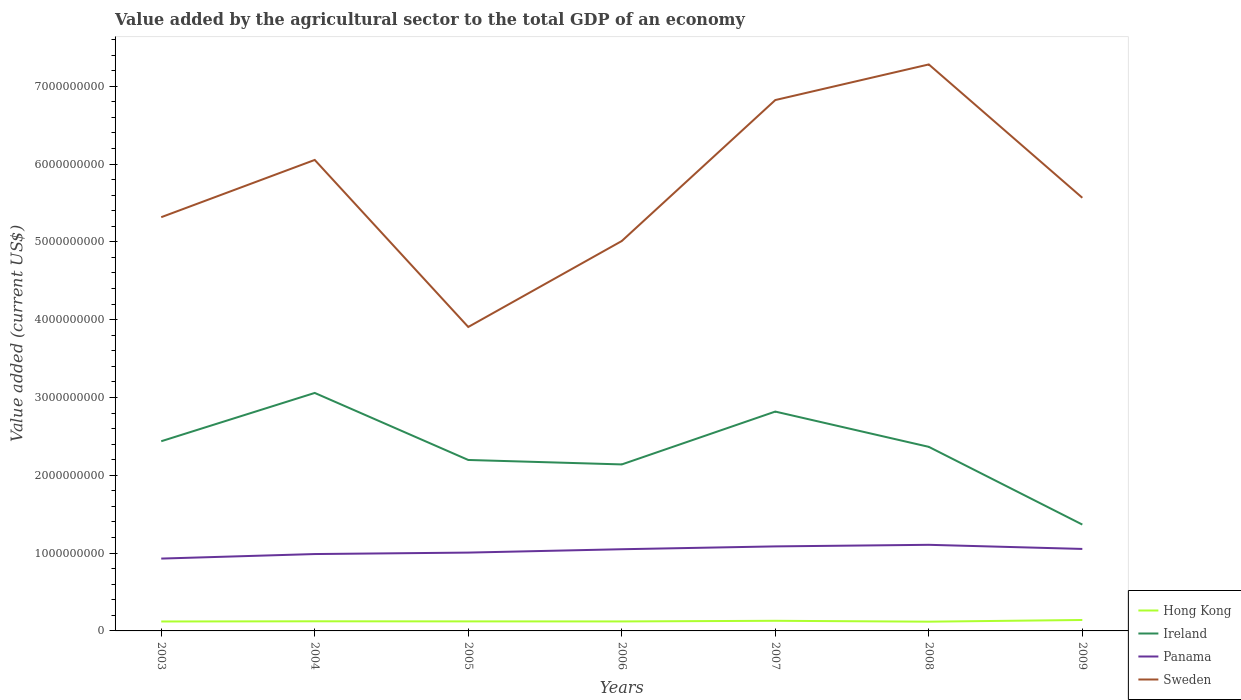How many different coloured lines are there?
Ensure brevity in your answer.  4. Is the number of lines equal to the number of legend labels?
Provide a succinct answer. Yes. Across all years, what is the maximum value added by the agricultural sector to the total GDP in Hong Kong?
Provide a short and direct response. 1.19e+08. In which year was the value added by the agricultural sector to the total GDP in Panama maximum?
Your response must be concise. 2003. What is the total value added by the agricultural sector to the total GDP in Ireland in the graph?
Offer a very short reply. 7.73e+08. What is the difference between the highest and the second highest value added by the agricultural sector to the total GDP in Panama?
Make the answer very short. 1.77e+08. What is the difference between the highest and the lowest value added by the agricultural sector to the total GDP in Sweden?
Offer a terse response. 3. How many lines are there?
Your answer should be compact. 4. Are the values on the major ticks of Y-axis written in scientific E-notation?
Your answer should be compact. No. Where does the legend appear in the graph?
Your answer should be very brief. Bottom right. How many legend labels are there?
Provide a succinct answer. 4. What is the title of the graph?
Your answer should be compact. Value added by the agricultural sector to the total GDP of an economy. Does "Montenegro" appear as one of the legend labels in the graph?
Give a very brief answer. No. What is the label or title of the Y-axis?
Give a very brief answer. Value added (current US$). What is the Value added (current US$) of Hong Kong in 2003?
Give a very brief answer. 1.21e+08. What is the Value added (current US$) of Ireland in 2003?
Provide a short and direct response. 2.44e+09. What is the Value added (current US$) of Panama in 2003?
Ensure brevity in your answer.  9.30e+08. What is the Value added (current US$) of Sweden in 2003?
Your answer should be very brief. 5.32e+09. What is the Value added (current US$) of Hong Kong in 2004?
Your answer should be compact. 1.24e+08. What is the Value added (current US$) in Ireland in 2004?
Keep it short and to the point. 3.06e+09. What is the Value added (current US$) of Panama in 2004?
Keep it short and to the point. 9.88e+08. What is the Value added (current US$) in Sweden in 2004?
Ensure brevity in your answer.  6.05e+09. What is the Value added (current US$) in Hong Kong in 2005?
Your answer should be very brief. 1.23e+08. What is the Value added (current US$) of Ireland in 2005?
Keep it short and to the point. 2.20e+09. What is the Value added (current US$) in Panama in 2005?
Keep it short and to the point. 1.01e+09. What is the Value added (current US$) of Sweden in 2005?
Offer a very short reply. 3.91e+09. What is the Value added (current US$) of Hong Kong in 2006?
Your answer should be very brief. 1.22e+08. What is the Value added (current US$) in Ireland in 2006?
Give a very brief answer. 2.14e+09. What is the Value added (current US$) of Panama in 2006?
Make the answer very short. 1.05e+09. What is the Value added (current US$) of Sweden in 2006?
Give a very brief answer. 5.01e+09. What is the Value added (current US$) of Hong Kong in 2007?
Provide a succinct answer. 1.30e+08. What is the Value added (current US$) of Ireland in 2007?
Provide a succinct answer. 2.82e+09. What is the Value added (current US$) of Panama in 2007?
Make the answer very short. 1.09e+09. What is the Value added (current US$) of Sweden in 2007?
Give a very brief answer. 6.82e+09. What is the Value added (current US$) of Hong Kong in 2008?
Give a very brief answer. 1.19e+08. What is the Value added (current US$) of Ireland in 2008?
Your answer should be very brief. 2.37e+09. What is the Value added (current US$) of Panama in 2008?
Keep it short and to the point. 1.11e+09. What is the Value added (current US$) in Sweden in 2008?
Give a very brief answer. 7.28e+09. What is the Value added (current US$) in Hong Kong in 2009?
Ensure brevity in your answer.  1.41e+08. What is the Value added (current US$) of Ireland in 2009?
Your answer should be very brief. 1.37e+09. What is the Value added (current US$) of Panama in 2009?
Offer a very short reply. 1.05e+09. What is the Value added (current US$) of Sweden in 2009?
Your answer should be very brief. 5.57e+09. Across all years, what is the maximum Value added (current US$) of Hong Kong?
Ensure brevity in your answer.  1.41e+08. Across all years, what is the maximum Value added (current US$) of Ireland?
Ensure brevity in your answer.  3.06e+09. Across all years, what is the maximum Value added (current US$) of Panama?
Make the answer very short. 1.11e+09. Across all years, what is the maximum Value added (current US$) in Sweden?
Your response must be concise. 7.28e+09. Across all years, what is the minimum Value added (current US$) of Hong Kong?
Offer a very short reply. 1.19e+08. Across all years, what is the minimum Value added (current US$) in Ireland?
Give a very brief answer. 1.37e+09. Across all years, what is the minimum Value added (current US$) of Panama?
Keep it short and to the point. 9.30e+08. Across all years, what is the minimum Value added (current US$) of Sweden?
Your answer should be very brief. 3.91e+09. What is the total Value added (current US$) of Hong Kong in the graph?
Offer a very short reply. 8.79e+08. What is the total Value added (current US$) in Ireland in the graph?
Provide a short and direct response. 1.64e+1. What is the total Value added (current US$) of Panama in the graph?
Give a very brief answer. 7.22e+09. What is the total Value added (current US$) in Sweden in the graph?
Keep it short and to the point. 4.00e+1. What is the difference between the Value added (current US$) in Hong Kong in 2003 and that in 2004?
Provide a short and direct response. -2.29e+06. What is the difference between the Value added (current US$) in Ireland in 2003 and that in 2004?
Offer a terse response. -6.21e+08. What is the difference between the Value added (current US$) in Panama in 2003 and that in 2004?
Ensure brevity in your answer.  -5.82e+07. What is the difference between the Value added (current US$) of Sweden in 2003 and that in 2004?
Your response must be concise. -7.36e+08. What is the difference between the Value added (current US$) in Hong Kong in 2003 and that in 2005?
Provide a succinct answer. -1.18e+06. What is the difference between the Value added (current US$) in Ireland in 2003 and that in 2005?
Offer a very short reply. 2.41e+08. What is the difference between the Value added (current US$) of Panama in 2003 and that in 2005?
Give a very brief answer. -7.70e+07. What is the difference between the Value added (current US$) of Sweden in 2003 and that in 2005?
Ensure brevity in your answer.  1.41e+09. What is the difference between the Value added (current US$) of Hong Kong in 2003 and that in 2006?
Ensure brevity in your answer.  -5.54e+05. What is the difference between the Value added (current US$) in Ireland in 2003 and that in 2006?
Ensure brevity in your answer.  2.98e+08. What is the difference between the Value added (current US$) in Panama in 2003 and that in 2006?
Offer a very short reply. -1.20e+08. What is the difference between the Value added (current US$) in Sweden in 2003 and that in 2006?
Provide a succinct answer. 3.06e+08. What is the difference between the Value added (current US$) of Hong Kong in 2003 and that in 2007?
Offer a terse response. -8.75e+06. What is the difference between the Value added (current US$) in Ireland in 2003 and that in 2007?
Your answer should be compact. -3.81e+08. What is the difference between the Value added (current US$) in Panama in 2003 and that in 2007?
Give a very brief answer. -1.57e+08. What is the difference between the Value added (current US$) in Sweden in 2003 and that in 2007?
Provide a short and direct response. -1.51e+09. What is the difference between the Value added (current US$) in Hong Kong in 2003 and that in 2008?
Offer a terse response. 2.57e+06. What is the difference between the Value added (current US$) in Ireland in 2003 and that in 2008?
Provide a short and direct response. 7.22e+07. What is the difference between the Value added (current US$) of Panama in 2003 and that in 2008?
Offer a very short reply. -1.77e+08. What is the difference between the Value added (current US$) of Sweden in 2003 and that in 2008?
Provide a succinct answer. -1.96e+09. What is the difference between the Value added (current US$) in Hong Kong in 2003 and that in 2009?
Ensure brevity in your answer.  -1.93e+07. What is the difference between the Value added (current US$) of Ireland in 2003 and that in 2009?
Ensure brevity in your answer.  1.07e+09. What is the difference between the Value added (current US$) in Panama in 2003 and that in 2009?
Provide a short and direct response. -1.24e+08. What is the difference between the Value added (current US$) in Sweden in 2003 and that in 2009?
Provide a succinct answer. -2.49e+08. What is the difference between the Value added (current US$) of Hong Kong in 2004 and that in 2005?
Offer a very short reply. 1.12e+06. What is the difference between the Value added (current US$) in Ireland in 2004 and that in 2005?
Offer a terse response. 8.61e+08. What is the difference between the Value added (current US$) of Panama in 2004 and that in 2005?
Offer a terse response. -1.88e+07. What is the difference between the Value added (current US$) in Sweden in 2004 and that in 2005?
Your answer should be very brief. 2.15e+09. What is the difference between the Value added (current US$) in Hong Kong in 2004 and that in 2006?
Ensure brevity in your answer.  1.74e+06. What is the difference between the Value added (current US$) in Ireland in 2004 and that in 2006?
Offer a very short reply. 9.19e+08. What is the difference between the Value added (current US$) of Panama in 2004 and that in 2006?
Your response must be concise. -6.20e+07. What is the difference between the Value added (current US$) of Sweden in 2004 and that in 2006?
Provide a short and direct response. 1.04e+09. What is the difference between the Value added (current US$) in Hong Kong in 2004 and that in 2007?
Your answer should be very brief. -6.45e+06. What is the difference between the Value added (current US$) in Ireland in 2004 and that in 2007?
Your answer should be compact. 2.40e+08. What is the difference between the Value added (current US$) in Panama in 2004 and that in 2007?
Your answer should be very brief. -9.84e+07. What is the difference between the Value added (current US$) in Sweden in 2004 and that in 2007?
Provide a short and direct response. -7.70e+08. What is the difference between the Value added (current US$) in Hong Kong in 2004 and that in 2008?
Your answer should be very brief. 4.86e+06. What is the difference between the Value added (current US$) of Ireland in 2004 and that in 2008?
Ensure brevity in your answer.  6.93e+08. What is the difference between the Value added (current US$) in Panama in 2004 and that in 2008?
Make the answer very short. -1.19e+08. What is the difference between the Value added (current US$) of Sweden in 2004 and that in 2008?
Your answer should be compact. -1.23e+09. What is the difference between the Value added (current US$) in Hong Kong in 2004 and that in 2009?
Keep it short and to the point. -1.70e+07. What is the difference between the Value added (current US$) of Ireland in 2004 and that in 2009?
Offer a terse response. 1.69e+09. What is the difference between the Value added (current US$) in Panama in 2004 and that in 2009?
Ensure brevity in your answer.  -6.57e+07. What is the difference between the Value added (current US$) of Sweden in 2004 and that in 2009?
Give a very brief answer. 4.86e+08. What is the difference between the Value added (current US$) in Hong Kong in 2005 and that in 2006?
Make the answer very short. 6.23e+05. What is the difference between the Value added (current US$) in Ireland in 2005 and that in 2006?
Give a very brief answer. 5.73e+07. What is the difference between the Value added (current US$) of Panama in 2005 and that in 2006?
Keep it short and to the point. -4.32e+07. What is the difference between the Value added (current US$) in Sweden in 2005 and that in 2006?
Offer a very short reply. -1.10e+09. What is the difference between the Value added (current US$) in Hong Kong in 2005 and that in 2007?
Provide a short and direct response. -7.57e+06. What is the difference between the Value added (current US$) in Ireland in 2005 and that in 2007?
Offer a terse response. -6.22e+08. What is the difference between the Value added (current US$) in Panama in 2005 and that in 2007?
Your answer should be very brief. -7.96e+07. What is the difference between the Value added (current US$) in Sweden in 2005 and that in 2007?
Offer a very short reply. -2.92e+09. What is the difference between the Value added (current US$) in Hong Kong in 2005 and that in 2008?
Make the answer very short. 3.75e+06. What is the difference between the Value added (current US$) in Ireland in 2005 and that in 2008?
Ensure brevity in your answer.  -1.69e+08. What is the difference between the Value added (current US$) of Panama in 2005 and that in 2008?
Provide a short and direct response. -1.00e+08. What is the difference between the Value added (current US$) in Sweden in 2005 and that in 2008?
Your answer should be very brief. -3.37e+09. What is the difference between the Value added (current US$) of Hong Kong in 2005 and that in 2009?
Your response must be concise. -1.81e+07. What is the difference between the Value added (current US$) in Ireland in 2005 and that in 2009?
Provide a short and direct response. 8.30e+08. What is the difference between the Value added (current US$) in Panama in 2005 and that in 2009?
Provide a short and direct response. -4.69e+07. What is the difference between the Value added (current US$) of Sweden in 2005 and that in 2009?
Provide a succinct answer. -1.66e+09. What is the difference between the Value added (current US$) in Hong Kong in 2006 and that in 2007?
Provide a succinct answer. -8.19e+06. What is the difference between the Value added (current US$) in Ireland in 2006 and that in 2007?
Offer a terse response. -6.79e+08. What is the difference between the Value added (current US$) in Panama in 2006 and that in 2007?
Your response must be concise. -3.64e+07. What is the difference between the Value added (current US$) of Sweden in 2006 and that in 2007?
Provide a short and direct response. -1.81e+09. What is the difference between the Value added (current US$) in Hong Kong in 2006 and that in 2008?
Offer a terse response. 3.12e+06. What is the difference between the Value added (current US$) of Ireland in 2006 and that in 2008?
Your answer should be very brief. -2.26e+08. What is the difference between the Value added (current US$) in Panama in 2006 and that in 2008?
Offer a terse response. -5.68e+07. What is the difference between the Value added (current US$) of Sweden in 2006 and that in 2008?
Your answer should be very brief. -2.27e+09. What is the difference between the Value added (current US$) of Hong Kong in 2006 and that in 2009?
Your answer should be very brief. -1.87e+07. What is the difference between the Value added (current US$) in Ireland in 2006 and that in 2009?
Your answer should be compact. 7.73e+08. What is the difference between the Value added (current US$) of Panama in 2006 and that in 2009?
Make the answer very short. -3.70e+06. What is the difference between the Value added (current US$) in Sweden in 2006 and that in 2009?
Your answer should be very brief. -5.56e+08. What is the difference between the Value added (current US$) of Hong Kong in 2007 and that in 2008?
Provide a succinct answer. 1.13e+07. What is the difference between the Value added (current US$) in Ireland in 2007 and that in 2008?
Ensure brevity in your answer.  4.53e+08. What is the difference between the Value added (current US$) in Panama in 2007 and that in 2008?
Make the answer very short. -2.04e+07. What is the difference between the Value added (current US$) in Sweden in 2007 and that in 2008?
Your answer should be compact. -4.58e+08. What is the difference between the Value added (current US$) of Hong Kong in 2007 and that in 2009?
Provide a succinct answer. -1.05e+07. What is the difference between the Value added (current US$) of Ireland in 2007 and that in 2009?
Offer a terse response. 1.45e+09. What is the difference between the Value added (current US$) of Panama in 2007 and that in 2009?
Give a very brief answer. 3.27e+07. What is the difference between the Value added (current US$) of Sweden in 2007 and that in 2009?
Make the answer very short. 1.26e+09. What is the difference between the Value added (current US$) in Hong Kong in 2008 and that in 2009?
Your answer should be compact. -2.18e+07. What is the difference between the Value added (current US$) of Ireland in 2008 and that in 2009?
Your answer should be very brief. 9.99e+08. What is the difference between the Value added (current US$) of Panama in 2008 and that in 2009?
Provide a short and direct response. 5.31e+07. What is the difference between the Value added (current US$) of Sweden in 2008 and that in 2009?
Provide a short and direct response. 1.71e+09. What is the difference between the Value added (current US$) of Hong Kong in 2003 and the Value added (current US$) of Ireland in 2004?
Ensure brevity in your answer.  -2.94e+09. What is the difference between the Value added (current US$) in Hong Kong in 2003 and the Value added (current US$) in Panama in 2004?
Give a very brief answer. -8.66e+08. What is the difference between the Value added (current US$) of Hong Kong in 2003 and the Value added (current US$) of Sweden in 2004?
Keep it short and to the point. -5.93e+09. What is the difference between the Value added (current US$) in Ireland in 2003 and the Value added (current US$) in Panama in 2004?
Ensure brevity in your answer.  1.45e+09. What is the difference between the Value added (current US$) of Ireland in 2003 and the Value added (current US$) of Sweden in 2004?
Keep it short and to the point. -3.61e+09. What is the difference between the Value added (current US$) of Panama in 2003 and the Value added (current US$) of Sweden in 2004?
Make the answer very short. -5.12e+09. What is the difference between the Value added (current US$) in Hong Kong in 2003 and the Value added (current US$) in Ireland in 2005?
Offer a very short reply. -2.08e+09. What is the difference between the Value added (current US$) in Hong Kong in 2003 and the Value added (current US$) in Panama in 2005?
Provide a short and direct response. -8.85e+08. What is the difference between the Value added (current US$) in Hong Kong in 2003 and the Value added (current US$) in Sweden in 2005?
Provide a short and direct response. -3.78e+09. What is the difference between the Value added (current US$) in Ireland in 2003 and the Value added (current US$) in Panama in 2005?
Keep it short and to the point. 1.43e+09. What is the difference between the Value added (current US$) in Ireland in 2003 and the Value added (current US$) in Sweden in 2005?
Make the answer very short. -1.47e+09. What is the difference between the Value added (current US$) in Panama in 2003 and the Value added (current US$) in Sweden in 2005?
Offer a very short reply. -2.98e+09. What is the difference between the Value added (current US$) of Hong Kong in 2003 and the Value added (current US$) of Ireland in 2006?
Your response must be concise. -2.02e+09. What is the difference between the Value added (current US$) in Hong Kong in 2003 and the Value added (current US$) in Panama in 2006?
Give a very brief answer. -9.28e+08. What is the difference between the Value added (current US$) of Hong Kong in 2003 and the Value added (current US$) of Sweden in 2006?
Offer a terse response. -4.89e+09. What is the difference between the Value added (current US$) of Ireland in 2003 and the Value added (current US$) of Panama in 2006?
Your response must be concise. 1.39e+09. What is the difference between the Value added (current US$) in Ireland in 2003 and the Value added (current US$) in Sweden in 2006?
Your response must be concise. -2.57e+09. What is the difference between the Value added (current US$) of Panama in 2003 and the Value added (current US$) of Sweden in 2006?
Your answer should be very brief. -4.08e+09. What is the difference between the Value added (current US$) of Hong Kong in 2003 and the Value added (current US$) of Ireland in 2007?
Offer a terse response. -2.70e+09. What is the difference between the Value added (current US$) of Hong Kong in 2003 and the Value added (current US$) of Panama in 2007?
Provide a succinct answer. -9.65e+08. What is the difference between the Value added (current US$) in Hong Kong in 2003 and the Value added (current US$) in Sweden in 2007?
Provide a succinct answer. -6.70e+09. What is the difference between the Value added (current US$) of Ireland in 2003 and the Value added (current US$) of Panama in 2007?
Provide a succinct answer. 1.35e+09. What is the difference between the Value added (current US$) in Ireland in 2003 and the Value added (current US$) in Sweden in 2007?
Your answer should be compact. -4.38e+09. What is the difference between the Value added (current US$) of Panama in 2003 and the Value added (current US$) of Sweden in 2007?
Your answer should be compact. -5.89e+09. What is the difference between the Value added (current US$) in Hong Kong in 2003 and the Value added (current US$) in Ireland in 2008?
Ensure brevity in your answer.  -2.24e+09. What is the difference between the Value added (current US$) of Hong Kong in 2003 and the Value added (current US$) of Panama in 2008?
Offer a very short reply. -9.85e+08. What is the difference between the Value added (current US$) in Hong Kong in 2003 and the Value added (current US$) in Sweden in 2008?
Provide a short and direct response. -7.16e+09. What is the difference between the Value added (current US$) in Ireland in 2003 and the Value added (current US$) in Panama in 2008?
Your answer should be very brief. 1.33e+09. What is the difference between the Value added (current US$) in Ireland in 2003 and the Value added (current US$) in Sweden in 2008?
Offer a very short reply. -4.84e+09. What is the difference between the Value added (current US$) of Panama in 2003 and the Value added (current US$) of Sweden in 2008?
Your answer should be very brief. -6.35e+09. What is the difference between the Value added (current US$) of Hong Kong in 2003 and the Value added (current US$) of Ireland in 2009?
Keep it short and to the point. -1.25e+09. What is the difference between the Value added (current US$) in Hong Kong in 2003 and the Value added (current US$) in Panama in 2009?
Your response must be concise. -9.32e+08. What is the difference between the Value added (current US$) in Hong Kong in 2003 and the Value added (current US$) in Sweden in 2009?
Offer a terse response. -5.44e+09. What is the difference between the Value added (current US$) of Ireland in 2003 and the Value added (current US$) of Panama in 2009?
Your answer should be compact. 1.38e+09. What is the difference between the Value added (current US$) of Ireland in 2003 and the Value added (current US$) of Sweden in 2009?
Ensure brevity in your answer.  -3.13e+09. What is the difference between the Value added (current US$) in Panama in 2003 and the Value added (current US$) in Sweden in 2009?
Your answer should be compact. -4.64e+09. What is the difference between the Value added (current US$) in Hong Kong in 2004 and the Value added (current US$) in Ireland in 2005?
Ensure brevity in your answer.  -2.07e+09. What is the difference between the Value added (current US$) in Hong Kong in 2004 and the Value added (current US$) in Panama in 2005?
Make the answer very short. -8.83e+08. What is the difference between the Value added (current US$) of Hong Kong in 2004 and the Value added (current US$) of Sweden in 2005?
Your answer should be compact. -3.78e+09. What is the difference between the Value added (current US$) in Ireland in 2004 and the Value added (current US$) in Panama in 2005?
Ensure brevity in your answer.  2.05e+09. What is the difference between the Value added (current US$) of Ireland in 2004 and the Value added (current US$) of Sweden in 2005?
Your answer should be compact. -8.48e+08. What is the difference between the Value added (current US$) of Panama in 2004 and the Value added (current US$) of Sweden in 2005?
Keep it short and to the point. -2.92e+09. What is the difference between the Value added (current US$) in Hong Kong in 2004 and the Value added (current US$) in Ireland in 2006?
Your response must be concise. -2.02e+09. What is the difference between the Value added (current US$) of Hong Kong in 2004 and the Value added (current US$) of Panama in 2006?
Offer a very short reply. -9.26e+08. What is the difference between the Value added (current US$) of Hong Kong in 2004 and the Value added (current US$) of Sweden in 2006?
Keep it short and to the point. -4.89e+09. What is the difference between the Value added (current US$) in Ireland in 2004 and the Value added (current US$) in Panama in 2006?
Provide a short and direct response. 2.01e+09. What is the difference between the Value added (current US$) of Ireland in 2004 and the Value added (current US$) of Sweden in 2006?
Your answer should be very brief. -1.95e+09. What is the difference between the Value added (current US$) in Panama in 2004 and the Value added (current US$) in Sweden in 2006?
Keep it short and to the point. -4.02e+09. What is the difference between the Value added (current US$) of Hong Kong in 2004 and the Value added (current US$) of Ireland in 2007?
Give a very brief answer. -2.70e+09. What is the difference between the Value added (current US$) in Hong Kong in 2004 and the Value added (current US$) in Panama in 2007?
Offer a terse response. -9.63e+08. What is the difference between the Value added (current US$) in Hong Kong in 2004 and the Value added (current US$) in Sweden in 2007?
Make the answer very short. -6.70e+09. What is the difference between the Value added (current US$) in Ireland in 2004 and the Value added (current US$) in Panama in 2007?
Offer a terse response. 1.97e+09. What is the difference between the Value added (current US$) in Ireland in 2004 and the Value added (current US$) in Sweden in 2007?
Give a very brief answer. -3.76e+09. What is the difference between the Value added (current US$) in Panama in 2004 and the Value added (current US$) in Sweden in 2007?
Your answer should be compact. -5.83e+09. What is the difference between the Value added (current US$) of Hong Kong in 2004 and the Value added (current US$) of Ireland in 2008?
Provide a succinct answer. -2.24e+09. What is the difference between the Value added (current US$) in Hong Kong in 2004 and the Value added (current US$) in Panama in 2008?
Your response must be concise. -9.83e+08. What is the difference between the Value added (current US$) of Hong Kong in 2004 and the Value added (current US$) of Sweden in 2008?
Keep it short and to the point. -7.16e+09. What is the difference between the Value added (current US$) of Ireland in 2004 and the Value added (current US$) of Panama in 2008?
Provide a short and direct response. 1.95e+09. What is the difference between the Value added (current US$) of Ireland in 2004 and the Value added (current US$) of Sweden in 2008?
Ensure brevity in your answer.  -4.22e+09. What is the difference between the Value added (current US$) in Panama in 2004 and the Value added (current US$) in Sweden in 2008?
Offer a very short reply. -6.29e+09. What is the difference between the Value added (current US$) in Hong Kong in 2004 and the Value added (current US$) in Ireland in 2009?
Your response must be concise. -1.24e+09. What is the difference between the Value added (current US$) of Hong Kong in 2004 and the Value added (current US$) of Panama in 2009?
Offer a very short reply. -9.30e+08. What is the difference between the Value added (current US$) in Hong Kong in 2004 and the Value added (current US$) in Sweden in 2009?
Provide a succinct answer. -5.44e+09. What is the difference between the Value added (current US$) of Ireland in 2004 and the Value added (current US$) of Panama in 2009?
Provide a succinct answer. 2.00e+09. What is the difference between the Value added (current US$) in Ireland in 2004 and the Value added (current US$) in Sweden in 2009?
Ensure brevity in your answer.  -2.51e+09. What is the difference between the Value added (current US$) of Panama in 2004 and the Value added (current US$) of Sweden in 2009?
Your answer should be compact. -4.58e+09. What is the difference between the Value added (current US$) in Hong Kong in 2005 and the Value added (current US$) in Ireland in 2006?
Make the answer very short. -2.02e+09. What is the difference between the Value added (current US$) in Hong Kong in 2005 and the Value added (current US$) in Panama in 2006?
Your response must be concise. -9.27e+08. What is the difference between the Value added (current US$) in Hong Kong in 2005 and the Value added (current US$) in Sweden in 2006?
Your answer should be very brief. -4.89e+09. What is the difference between the Value added (current US$) in Ireland in 2005 and the Value added (current US$) in Panama in 2006?
Offer a terse response. 1.15e+09. What is the difference between the Value added (current US$) in Ireland in 2005 and the Value added (current US$) in Sweden in 2006?
Ensure brevity in your answer.  -2.81e+09. What is the difference between the Value added (current US$) of Panama in 2005 and the Value added (current US$) of Sweden in 2006?
Provide a succinct answer. -4.00e+09. What is the difference between the Value added (current US$) of Hong Kong in 2005 and the Value added (current US$) of Ireland in 2007?
Your answer should be very brief. -2.70e+09. What is the difference between the Value added (current US$) in Hong Kong in 2005 and the Value added (current US$) in Panama in 2007?
Offer a very short reply. -9.64e+08. What is the difference between the Value added (current US$) of Hong Kong in 2005 and the Value added (current US$) of Sweden in 2007?
Ensure brevity in your answer.  -6.70e+09. What is the difference between the Value added (current US$) of Ireland in 2005 and the Value added (current US$) of Panama in 2007?
Your answer should be very brief. 1.11e+09. What is the difference between the Value added (current US$) in Ireland in 2005 and the Value added (current US$) in Sweden in 2007?
Provide a short and direct response. -4.63e+09. What is the difference between the Value added (current US$) of Panama in 2005 and the Value added (current US$) of Sweden in 2007?
Keep it short and to the point. -5.82e+09. What is the difference between the Value added (current US$) in Hong Kong in 2005 and the Value added (current US$) in Ireland in 2008?
Make the answer very short. -2.24e+09. What is the difference between the Value added (current US$) of Hong Kong in 2005 and the Value added (current US$) of Panama in 2008?
Give a very brief answer. -9.84e+08. What is the difference between the Value added (current US$) in Hong Kong in 2005 and the Value added (current US$) in Sweden in 2008?
Your answer should be compact. -7.16e+09. What is the difference between the Value added (current US$) in Ireland in 2005 and the Value added (current US$) in Panama in 2008?
Offer a terse response. 1.09e+09. What is the difference between the Value added (current US$) of Ireland in 2005 and the Value added (current US$) of Sweden in 2008?
Your answer should be compact. -5.08e+09. What is the difference between the Value added (current US$) in Panama in 2005 and the Value added (current US$) in Sweden in 2008?
Your answer should be compact. -6.27e+09. What is the difference between the Value added (current US$) of Hong Kong in 2005 and the Value added (current US$) of Ireland in 2009?
Keep it short and to the point. -1.24e+09. What is the difference between the Value added (current US$) in Hong Kong in 2005 and the Value added (current US$) in Panama in 2009?
Your response must be concise. -9.31e+08. What is the difference between the Value added (current US$) in Hong Kong in 2005 and the Value added (current US$) in Sweden in 2009?
Offer a very short reply. -5.44e+09. What is the difference between the Value added (current US$) in Ireland in 2005 and the Value added (current US$) in Panama in 2009?
Keep it short and to the point. 1.14e+09. What is the difference between the Value added (current US$) in Ireland in 2005 and the Value added (current US$) in Sweden in 2009?
Give a very brief answer. -3.37e+09. What is the difference between the Value added (current US$) of Panama in 2005 and the Value added (current US$) of Sweden in 2009?
Provide a succinct answer. -4.56e+09. What is the difference between the Value added (current US$) of Hong Kong in 2006 and the Value added (current US$) of Ireland in 2007?
Ensure brevity in your answer.  -2.70e+09. What is the difference between the Value added (current US$) of Hong Kong in 2006 and the Value added (current US$) of Panama in 2007?
Your answer should be very brief. -9.64e+08. What is the difference between the Value added (current US$) in Hong Kong in 2006 and the Value added (current US$) in Sweden in 2007?
Your answer should be very brief. -6.70e+09. What is the difference between the Value added (current US$) of Ireland in 2006 and the Value added (current US$) of Panama in 2007?
Offer a terse response. 1.05e+09. What is the difference between the Value added (current US$) in Ireland in 2006 and the Value added (current US$) in Sweden in 2007?
Keep it short and to the point. -4.68e+09. What is the difference between the Value added (current US$) in Panama in 2006 and the Value added (current US$) in Sweden in 2007?
Give a very brief answer. -5.77e+09. What is the difference between the Value added (current US$) in Hong Kong in 2006 and the Value added (current US$) in Ireland in 2008?
Keep it short and to the point. -2.24e+09. What is the difference between the Value added (current US$) in Hong Kong in 2006 and the Value added (current US$) in Panama in 2008?
Make the answer very short. -9.85e+08. What is the difference between the Value added (current US$) of Hong Kong in 2006 and the Value added (current US$) of Sweden in 2008?
Make the answer very short. -7.16e+09. What is the difference between the Value added (current US$) in Ireland in 2006 and the Value added (current US$) in Panama in 2008?
Your answer should be compact. 1.03e+09. What is the difference between the Value added (current US$) of Ireland in 2006 and the Value added (current US$) of Sweden in 2008?
Keep it short and to the point. -5.14e+09. What is the difference between the Value added (current US$) in Panama in 2006 and the Value added (current US$) in Sweden in 2008?
Provide a succinct answer. -6.23e+09. What is the difference between the Value added (current US$) in Hong Kong in 2006 and the Value added (current US$) in Ireland in 2009?
Provide a succinct answer. -1.24e+09. What is the difference between the Value added (current US$) of Hong Kong in 2006 and the Value added (current US$) of Panama in 2009?
Offer a very short reply. -9.32e+08. What is the difference between the Value added (current US$) in Hong Kong in 2006 and the Value added (current US$) in Sweden in 2009?
Keep it short and to the point. -5.44e+09. What is the difference between the Value added (current US$) of Ireland in 2006 and the Value added (current US$) of Panama in 2009?
Keep it short and to the point. 1.09e+09. What is the difference between the Value added (current US$) of Ireland in 2006 and the Value added (current US$) of Sweden in 2009?
Give a very brief answer. -3.43e+09. What is the difference between the Value added (current US$) of Panama in 2006 and the Value added (current US$) of Sweden in 2009?
Your answer should be compact. -4.52e+09. What is the difference between the Value added (current US$) of Hong Kong in 2007 and the Value added (current US$) of Ireland in 2008?
Your response must be concise. -2.24e+09. What is the difference between the Value added (current US$) of Hong Kong in 2007 and the Value added (current US$) of Panama in 2008?
Give a very brief answer. -9.76e+08. What is the difference between the Value added (current US$) of Hong Kong in 2007 and the Value added (current US$) of Sweden in 2008?
Ensure brevity in your answer.  -7.15e+09. What is the difference between the Value added (current US$) in Ireland in 2007 and the Value added (current US$) in Panama in 2008?
Your response must be concise. 1.71e+09. What is the difference between the Value added (current US$) of Ireland in 2007 and the Value added (current US$) of Sweden in 2008?
Your response must be concise. -4.46e+09. What is the difference between the Value added (current US$) of Panama in 2007 and the Value added (current US$) of Sweden in 2008?
Keep it short and to the point. -6.19e+09. What is the difference between the Value added (current US$) in Hong Kong in 2007 and the Value added (current US$) in Ireland in 2009?
Make the answer very short. -1.24e+09. What is the difference between the Value added (current US$) in Hong Kong in 2007 and the Value added (current US$) in Panama in 2009?
Make the answer very short. -9.23e+08. What is the difference between the Value added (current US$) in Hong Kong in 2007 and the Value added (current US$) in Sweden in 2009?
Provide a short and direct response. -5.44e+09. What is the difference between the Value added (current US$) in Ireland in 2007 and the Value added (current US$) in Panama in 2009?
Offer a terse response. 1.77e+09. What is the difference between the Value added (current US$) of Ireland in 2007 and the Value added (current US$) of Sweden in 2009?
Your answer should be compact. -2.75e+09. What is the difference between the Value added (current US$) of Panama in 2007 and the Value added (current US$) of Sweden in 2009?
Provide a succinct answer. -4.48e+09. What is the difference between the Value added (current US$) in Hong Kong in 2008 and the Value added (current US$) in Ireland in 2009?
Your response must be concise. -1.25e+09. What is the difference between the Value added (current US$) of Hong Kong in 2008 and the Value added (current US$) of Panama in 2009?
Your answer should be compact. -9.35e+08. What is the difference between the Value added (current US$) in Hong Kong in 2008 and the Value added (current US$) in Sweden in 2009?
Keep it short and to the point. -5.45e+09. What is the difference between the Value added (current US$) of Ireland in 2008 and the Value added (current US$) of Panama in 2009?
Provide a succinct answer. 1.31e+09. What is the difference between the Value added (current US$) of Ireland in 2008 and the Value added (current US$) of Sweden in 2009?
Give a very brief answer. -3.20e+09. What is the difference between the Value added (current US$) in Panama in 2008 and the Value added (current US$) in Sweden in 2009?
Your answer should be compact. -4.46e+09. What is the average Value added (current US$) of Hong Kong per year?
Provide a short and direct response. 1.26e+08. What is the average Value added (current US$) in Ireland per year?
Your answer should be very brief. 2.34e+09. What is the average Value added (current US$) of Panama per year?
Your answer should be very brief. 1.03e+09. What is the average Value added (current US$) of Sweden per year?
Provide a short and direct response. 5.71e+09. In the year 2003, what is the difference between the Value added (current US$) in Hong Kong and Value added (current US$) in Ireland?
Provide a succinct answer. -2.32e+09. In the year 2003, what is the difference between the Value added (current US$) of Hong Kong and Value added (current US$) of Panama?
Keep it short and to the point. -8.08e+08. In the year 2003, what is the difference between the Value added (current US$) of Hong Kong and Value added (current US$) of Sweden?
Your answer should be compact. -5.20e+09. In the year 2003, what is the difference between the Value added (current US$) of Ireland and Value added (current US$) of Panama?
Your response must be concise. 1.51e+09. In the year 2003, what is the difference between the Value added (current US$) in Ireland and Value added (current US$) in Sweden?
Offer a terse response. -2.88e+09. In the year 2003, what is the difference between the Value added (current US$) in Panama and Value added (current US$) in Sweden?
Make the answer very short. -4.39e+09. In the year 2004, what is the difference between the Value added (current US$) of Hong Kong and Value added (current US$) of Ireland?
Ensure brevity in your answer.  -2.93e+09. In the year 2004, what is the difference between the Value added (current US$) in Hong Kong and Value added (current US$) in Panama?
Provide a succinct answer. -8.64e+08. In the year 2004, what is the difference between the Value added (current US$) of Hong Kong and Value added (current US$) of Sweden?
Make the answer very short. -5.93e+09. In the year 2004, what is the difference between the Value added (current US$) in Ireland and Value added (current US$) in Panama?
Your answer should be very brief. 2.07e+09. In the year 2004, what is the difference between the Value added (current US$) in Ireland and Value added (current US$) in Sweden?
Give a very brief answer. -2.99e+09. In the year 2004, what is the difference between the Value added (current US$) in Panama and Value added (current US$) in Sweden?
Provide a succinct answer. -5.06e+09. In the year 2005, what is the difference between the Value added (current US$) in Hong Kong and Value added (current US$) in Ireland?
Your response must be concise. -2.07e+09. In the year 2005, what is the difference between the Value added (current US$) in Hong Kong and Value added (current US$) in Panama?
Keep it short and to the point. -8.84e+08. In the year 2005, what is the difference between the Value added (current US$) of Hong Kong and Value added (current US$) of Sweden?
Offer a terse response. -3.78e+09. In the year 2005, what is the difference between the Value added (current US$) of Ireland and Value added (current US$) of Panama?
Keep it short and to the point. 1.19e+09. In the year 2005, what is the difference between the Value added (current US$) of Ireland and Value added (current US$) of Sweden?
Keep it short and to the point. -1.71e+09. In the year 2005, what is the difference between the Value added (current US$) of Panama and Value added (current US$) of Sweden?
Ensure brevity in your answer.  -2.90e+09. In the year 2006, what is the difference between the Value added (current US$) in Hong Kong and Value added (current US$) in Ireland?
Provide a succinct answer. -2.02e+09. In the year 2006, what is the difference between the Value added (current US$) of Hong Kong and Value added (current US$) of Panama?
Offer a very short reply. -9.28e+08. In the year 2006, what is the difference between the Value added (current US$) of Hong Kong and Value added (current US$) of Sweden?
Offer a terse response. -4.89e+09. In the year 2006, what is the difference between the Value added (current US$) of Ireland and Value added (current US$) of Panama?
Give a very brief answer. 1.09e+09. In the year 2006, what is the difference between the Value added (current US$) in Ireland and Value added (current US$) in Sweden?
Make the answer very short. -2.87e+09. In the year 2006, what is the difference between the Value added (current US$) in Panama and Value added (current US$) in Sweden?
Keep it short and to the point. -3.96e+09. In the year 2007, what is the difference between the Value added (current US$) in Hong Kong and Value added (current US$) in Ireland?
Give a very brief answer. -2.69e+09. In the year 2007, what is the difference between the Value added (current US$) in Hong Kong and Value added (current US$) in Panama?
Offer a very short reply. -9.56e+08. In the year 2007, what is the difference between the Value added (current US$) in Hong Kong and Value added (current US$) in Sweden?
Ensure brevity in your answer.  -6.69e+09. In the year 2007, what is the difference between the Value added (current US$) in Ireland and Value added (current US$) in Panama?
Your answer should be very brief. 1.73e+09. In the year 2007, what is the difference between the Value added (current US$) of Ireland and Value added (current US$) of Sweden?
Offer a very short reply. -4.00e+09. In the year 2007, what is the difference between the Value added (current US$) in Panama and Value added (current US$) in Sweden?
Give a very brief answer. -5.74e+09. In the year 2008, what is the difference between the Value added (current US$) of Hong Kong and Value added (current US$) of Ireland?
Offer a terse response. -2.25e+09. In the year 2008, what is the difference between the Value added (current US$) in Hong Kong and Value added (current US$) in Panama?
Keep it short and to the point. -9.88e+08. In the year 2008, what is the difference between the Value added (current US$) in Hong Kong and Value added (current US$) in Sweden?
Provide a short and direct response. -7.16e+09. In the year 2008, what is the difference between the Value added (current US$) of Ireland and Value added (current US$) of Panama?
Make the answer very short. 1.26e+09. In the year 2008, what is the difference between the Value added (current US$) in Ireland and Value added (current US$) in Sweden?
Ensure brevity in your answer.  -4.91e+09. In the year 2008, what is the difference between the Value added (current US$) in Panama and Value added (current US$) in Sweden?
Give a very brief answer. -6.17e+09. In the year 2009, what is the difference between the Value added (current US$) of Hong Kong and Value added (current US$) of Ireland?
Provide a short and direct response. -1.23e+09. In the year 2009, what is the difference between the Value added (current US$) in Hong Kong and Value added (current US$) in Panama?
Provide a succinct answer. -9.13e+08. In the year 2009, what is the difference between the Value added (current US$) in Hong Kong and Value added (current US$) in Sweden?
Your response must be concise. -5.43e+09. In the year 2009, what is the difference between the Value added (current US$) of Ireland and Value added (current US$) of Panama?
Offer a terse response. 3.13e+08. In the year 2009, what is the difference between the Value added (current US$) in Ireland and Value added (current US$) in Sweden?
Your answer should be very brief. -4.20e+09. In the year 2009, what is the difference between the Value added (current US$) in Panama and Value added (current US$) in Sweden?
Provide a short and direct response. -4.51e+09. What is the ratio of the Value added (current US$) in Hong Kong in 2003 to that in 2004?
Make the answer very short. 0.98. What is the ratio of the Value added (current US$) of Ireland in 2003 to that in 2004?
Your answer should be compact. 0.8. What is the ratio of the Value added (current US$) of Panama in 2003 to that in 2004?
Offer a terse response. 0.94. What is the ratio of the Value added (current US$) of Sweden in 2003 to that in 2004?
Ensure brevity in your answer.  0.88. What is the ratio of the Value added (current US$) of Ireland in 2003 to that in 2005?
Ensure brevity in your answer.  1.11. What is the ratio of the Value added (current US$) in Panama in 2003 to that in 2005?
Give a very brief answer. 0.92. What is the ratio of the Value added (current US$) of Sweden in 2003 to that in 2005?
Offer a terse response. 1.36. What is the ratio of the Value added (current US$) in Hong Kong in 2003 to that in 2006?
Your response must be concise. 1. What is the ratio of the Value added (current US$) of Ireland in 2003 to that in 2006?
Make the answer very short. 1.14. What is the ratio of the Value added (current US$) in Panama in 2003 to that in 2006?
Your response must be concise. 0.89. What is the ratio of the Value added (current US$) of Sweden in 2003 to that in 2006?
Your answer should be compact. 1.06. What is the ratio of the Value added (current US$) of Hong Kong in 2003 to that in 2007?
Make the answer very short. 0.93. What is the ratio of the Value added (current US$) in Ireland in 2003 to that in 2007?
Make the answer very short. 0.86. What is the ratio of the Value added (current US$) of Panama in 2003 to that in 2007?
Give a very brief answer. 0.86. What is the ratio of the Value added (current US$) of Sweden in 2003 to that in 2007?
Your response must be concise. 0.78. What is the ratio of the Value added (current US$) in Hong Kong in 2003 to that in 2008?
Offer a terse response. 1.02. What is the ratio of the Value added (current US$) of Ireland in 2003 to that in 2008?
Ensure brevity in your answer.  1.03. What is the ratio of the Value added (current US$) of Panama in 2003 to that in 2008?
Your answer should be compact. 0.84. What is the ratio of the Value added (current US$) in Sweden in 2003 to that in 2008?
Provide a succinct answer. 0.73. What is the ratio of the Value added (current US$) of Hong Kong in 2003 to that in 2009?
Give a very brief answer. 0.86. What is the ratio of the Value added (current US$) of Ireland in 2003 to that in 2009?
Your answer should be very brief. 1.78. What is the ratio of the Value added (current US$) of Panama in 2003 to that in 2009?
Offer a very short reply. 0.88. What is the ratio of the Value added (current US$) of Sweden in 2003 to that in 2009?
Your answer should be compact. 0.96. What is the ratio of the Value added (current US$) in Hong Kong in 2004 to that in 2005?
Make the answer very short. 1.01. What is the ratio of the Value added (current US$) in Ireland in 2004 to that in 2005?
Offer a terse response. 1.39. What is the ratio of the Value added (current US$) of Panama in 2004 to that in 2005?
Keep it short and to the point. 0.98. What is the ratio of the Value added (current US$) of Sweden in 2004 to that in 2005?
Offer a very short reply. 1.55. What is the ratio of the Value added (current US$) of Hong Kong in 2004 to that in 2006?
Offer a terse response. 1.01. What is the ratio of the Value added (current US$) in Ireland in 2004 to that in 2006?
Give a very brief answer. 1.43. What is the ratio of the Value added (current US$) of Panama in 2004 to that in 2006?
Ensure brevity in your answer.  0.94. What is the ratio of the Value added (current US$) of Sweden in 2004 to that in 2006?
Offer a very short reply. 1.21. What is the ratio of the Value added (current US$) in Hong Kong in 2004 to that in 2007?
Offer a very short reply. 0.95. What is the ratio of the Value added (current US$) in Ireland in 2004 to that in 2007?
Your response must be concise. 1.08. What is the ratio of the Value added (current US$) of Panama in 2004 to that in 2007?
Your response must be concise. 0.91. What is the ratio of the Value added (current US$) in Sweden in 2004 to that in 2007?
Provide a short and direct response. 0.89. What is the ratio of the Value added (current US$) of Hong Kong in 2004 to that in 2008?
Your answer should be compact. 1.04. What is the ratio of the Value added (current US$) of Ireland in 2004 to that in 2008?
Keep it short and to the point. 1.29. What is the ratio of the Value added (current US$) of Panama in 2004 to that in 2008?
Make the answer very short. 0.89. What is the ratio of the Value added (current US$) of Sweden in 2004 to that in 2008?
Give a very brief answer. 0.83. What is the ratio of the Value added (current US$) in Hong Kong in 2004 to that in 2009?
Your response must be concise. 0.88. What is the ratio of the Value added (current US$) in Ireland in 2004 to that in 2009?
Offer a terse response. 2.24. What is the ratio of the Value added (current US$) of Panama in 2004 to that in 2009?
Ensure brevity in your answer.  0.94. What is the ratio of the Value added (current US$) of Sweden in 2004 to that in 2009?
Provide a succinct answer. 1.09. What is the ratio of the Value added (current US$) of Hong Kong in 2005 to that in 2006?
Provide a short and direct response. 1.01. What is the ratio of the Value added (current US$) in Ireland in 2005 to that in 2006?
Offer a very short reply. 1.03. What is the ratio of the Value added (current US$) in Panama in 2005 to that in 2006?
Ensure brevity in your answer.  0.96. What is the ratio of the Value added (current US$) in Sweden in 2005 to that in 2006?
Ensure brevity in your answer.  0.78. What is the ratio of the Value added (current US$) of Hong Kong in 2005 to that in 2007?
Provide a succinct answer. 0.94. What is the ratio of the Value added (current US$) in Ireland in 2005 to that in 2007?
Your answer should be very brief. 0.78. What is the ratio of the Value added (current US$) in Panama in 2005 to that in 2007?
Keep it short and to the point. 0.93. What is the ratio of the Value added (current US$) in Sweden in 2005 to that in 2007?
Keep it short and to the point. 0.57. What is the ratio of the Value added (current US$) of Hong Kong in 2005 to that in 2008?
Your response must be concise. 1.03. What is the ratio of the Value added (current US$) of Ireland in 2005 to that in 2008?
Offer a terse response. 0.93. What is the ratio of the Value added (current US$) of Panama in 2005 to that in 2008?
Your response must be concise. 0.91. What is the ratio of the Value added (current US$) of Sweden in 2005 to that in 2008?
Provide a short and direct response. 0.54. What is the ratio of the Value added (current US$) in Hong Kong in 2005 to that in 2009?
Offer a terse response. 0.87. What is the ratio of the Value added (current US$) of Ireland in 2005 to that in 2009?
Make the answer very short. 1.61. What is the ratio of the Value added (current US$) of Panama in 2005 to that in 2009?
Provide a succinct answer. 0.96. What is the ratio of the Value added (current US$) of Sweden in 2005 to that in 2009?
Keep it short and to the point. 0.7. What is the ratio of the Value added (current US$) of Hong Kong in 2006 to that in 2007?
Your answer should be compact. 0.94. What is the ratio of the Value added (current US$) in Ireland in 2006 to that in 2007?
Your answer should be very brief. 0.76. What is the ratio of the Value added (current US$) of Panama in 2006 to that in 2007?
Your answer should be very brief. 0.97. What is the ratio of the Value added (current US$) of Sweden in 2006 to that in 2007?
Give a very brief answer. 0.73. What is the ratio of the Value added (current US$) of Hong Kong in 2006 to that in 2008?
Offer a terse response. 1.03. What is the ratio of the Value added (current US$) of Ireland in 2006 to that in 2008?
Make the answer very short. 0.9. What is the ratio of the Value added (current US$) in Panama in 2006 to that in 2008?
Make the answer very short. 0.95. What is the ratio of the Value added (current US$) of Sweden in 2006 to that in 2008?
Ensure brevity in your answer.  0.69. What is the ratio of the Value added (current US$) in Hong Kong in 2006 to that in 2009?
Make the answer very short. 0.87. What is the ratio of the Value added (current US$) of Ireland in 2006 to that in 2009?
Keep it short and to the point. 1.57. What is the ratio of the Value added (current US$) of Sweden in 2006 to that in 2009?
Offer a terse response. 0.9. What is the ratio of the Value added (current US$) of Hong Kong in 2007 to that in 2008?
Offer a very short reply. 1.1. What is the ratio of the Value added (current US$) in Ireland in 2007 to that in 2008?
Your answer should be compact. 1.19. What is the ratio of the Value added (current US$) in Panama in 2007 to that in 2008?
Your response must be concise. 0.98. What is the ratio of the Value added (current US$) of Sweden in 2007 to that in 2008?
Provide a succinct answer. 0.94. What is the ratio of the Value added (current US$) of Hong Kong in 2007 to that in 2009?
Provide a short and direct response. 0.93. What is the ratio of the Value added (current US$) of Ireland in 2007 to that in 2009?
Your answer should be very brief. 2.06. What is the ratio of the Value added (current US$) of Panama in 2007 to that in 2009?
Your response must be concise. 1.03. What is the ratio of the Value added (current US$) in Sweden in 2007 to that in 2009?
Offer a terse response. 1.23. What is the ratio of the Value added (current US$) in Hong Kong in 2008 to that in 2009?
Give a very brief answer. 0.84. What is the ratio of the Value added (current US$) of Ireland in 2008 to that in 2009?
Keep it short and to the point. 1.73. What is the ratio of the Value added (current US$) of Panama in 2008 to that in 2009?
Provide a succinct answer. 1.05. What is the ratio of the Value added (current US$) in Sweden in 2008 to that in 2009?
Your response must be concise. 1.31. What is the difference between the highest and the second highest Value added (current US$) in Hong Kong?
Give a very brief answer. 1.05e+07. What is the difference between the highest and the second highest Value added (current US$) of Ireland?
Keep it short and to the point. 2.40e+08. What is the difference between the highest and the second highest Value added (current US$) of Panama?
Give a very brief answer. 2.04e+07. What is the difference between the highest and the second highest Value added (current US$) of Sweden?
Keep it short and to the point. 4.58e+08. What is the difference between the highest and the lowest Value added (current US$) in Hong Kong?
Your answer should be very brief. 2.18e+07. What is the difference between the highest and the lowest Value added (current US$) in Ireland?
Provide a succinct answer. 1.69e+09. What is the difference between the highest and the lowest Value added (current US$) in Panama?
Provide a succinct answer. 1.77e+08. What is the difference between the highest and the lowest Value added (current US$) in Sweden?
Offer a very short reply. 3.37e+09. 